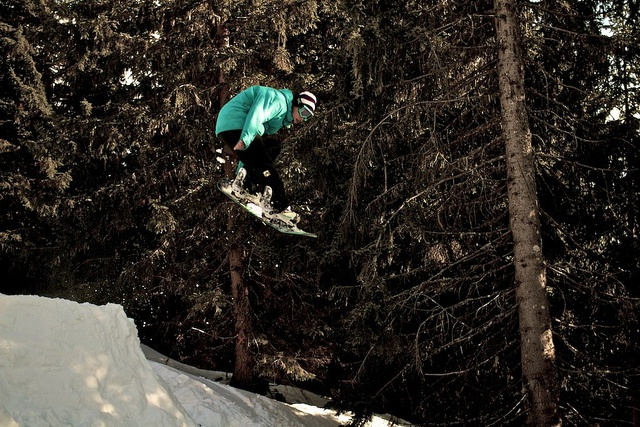Describe the objects in this image and their specific colors. I can see people in black, teal, and ivory tones and snowboard in black, gray, darkgray, and beige tones in this image. 